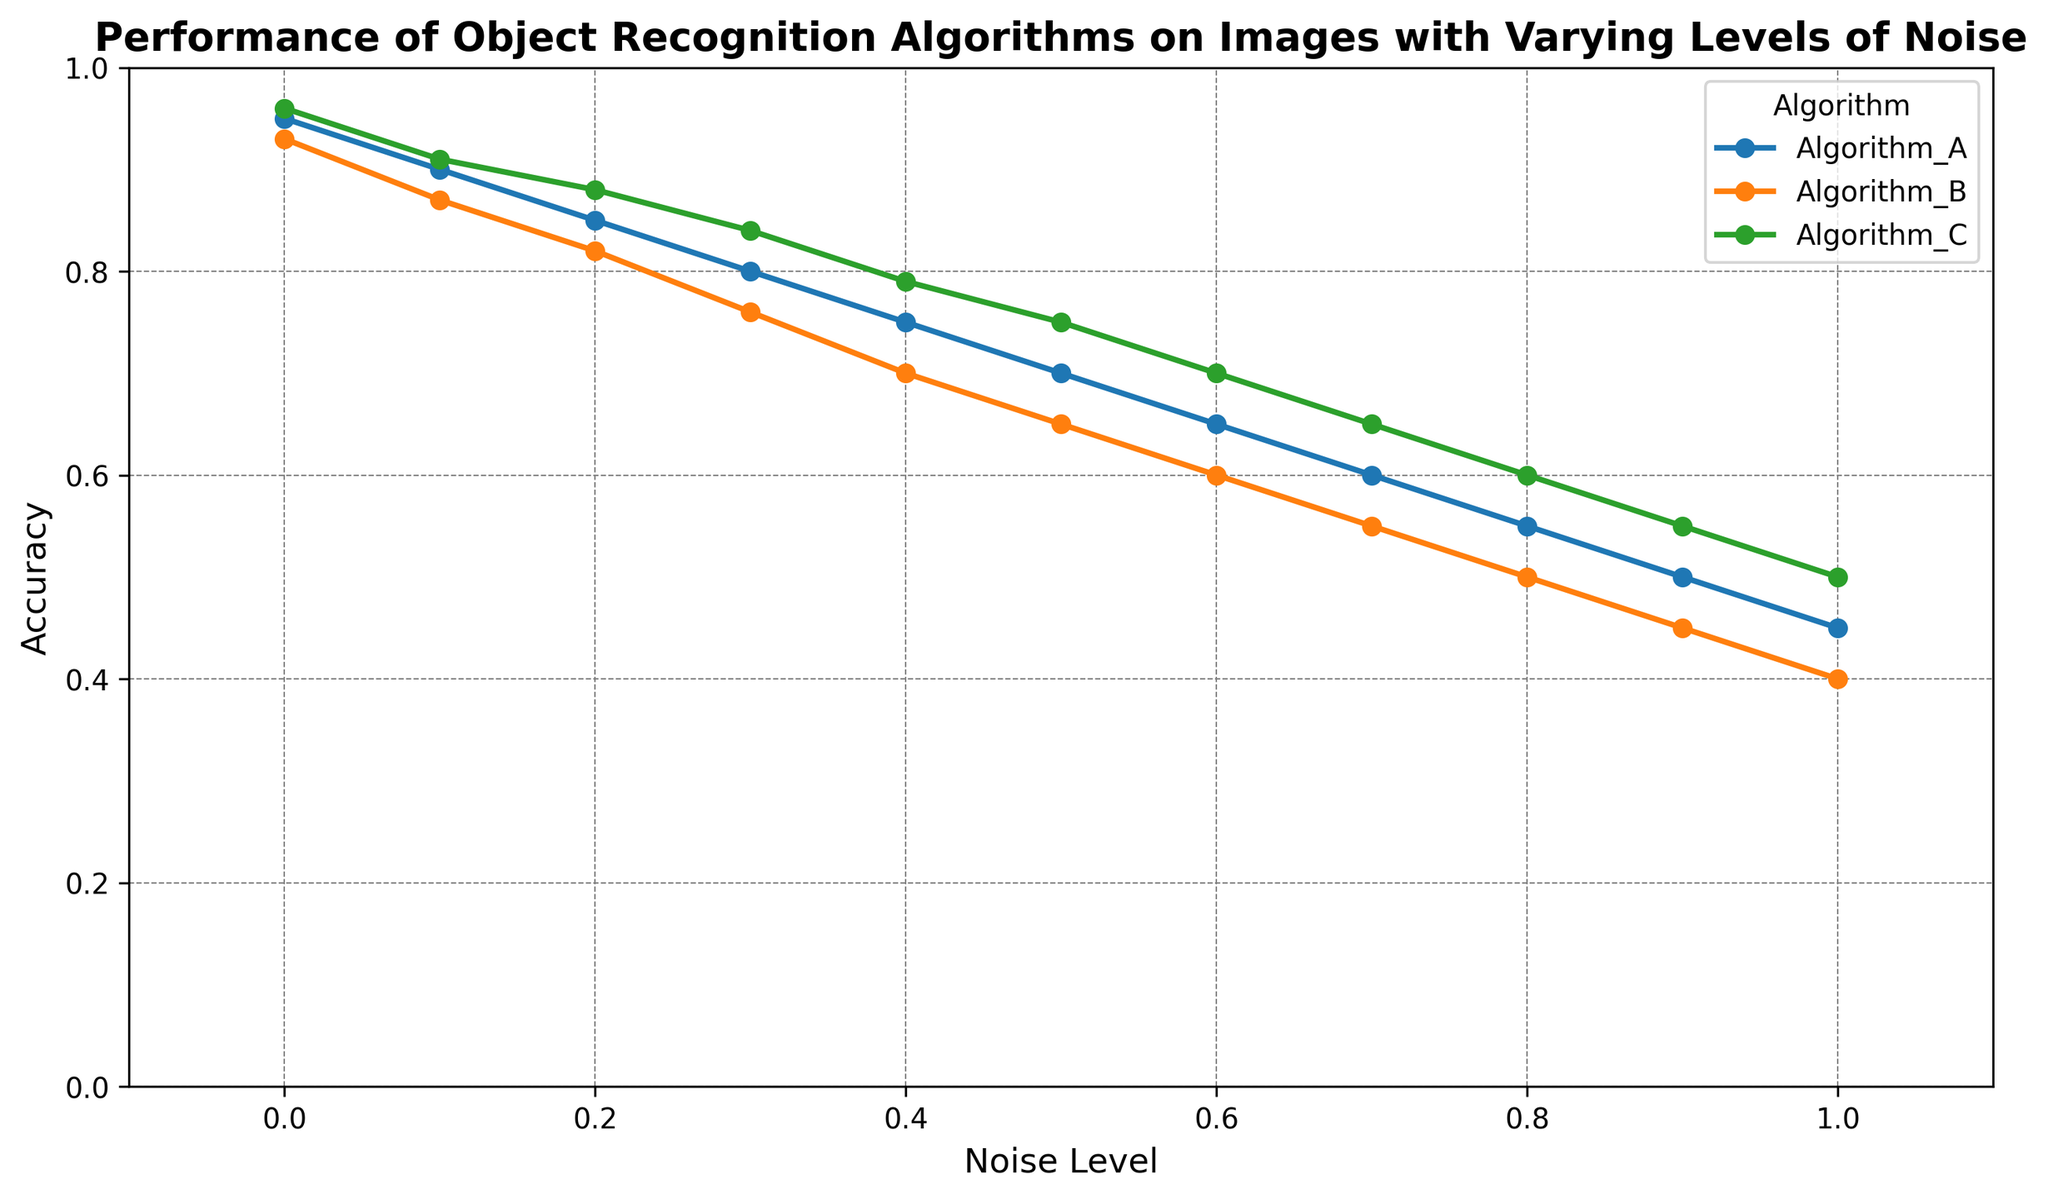What is the highest accuracy achieved by any algorithm at the noise level of 0.3? The chart shows that at a noise level of 0.3, Algorithm C has the highest accuracy of 0.84. This is determined by looking at the values on the y-axis corresponding to the noise level of 0.3 for each algorithm and selecting the maximum value.
Answer: 0.84 Which algorithm performs the best at the maximum noise level of 1.0? Looking at the chart, at the noise level of 1.0, Algorithm C has the highest accuracy with a value of 0.50. This is identified by comparing the accuracies of all three algorithms at the noise level of 1.0.
Answer: Algorithm_C How does the accuracy of Algorithm A change when the noise level increases from 0.2 to 0.5? The accuracy of Algorithm A decreases from 0.85 at the noise level of 0.2 to 0.70 at the noise level of 0.5. The change can be calculated by subtracting the accuracy at 0.5 from the accuracy at 0.2: 0.85 - 0.70 = 0.15.
Answer: Decreases by 0.15 Which algorithm shows the least variation in accuracy across different noise levels? By visually inspecting the chart, Algorithm C has the highest minimum accuracy and the lowest reduction in accuracy as the noise level increases, indicating the most stable performance among the algorithms.
Answer: Algorithm_C At a noise level of 0.8, which algorithm has the lowest accuracy, and what is it? At noise level 0.8, Algorithm B has the lowest accuracy of 0.50. This can be determined by examining the accuracy values for all algorithms at noise level 0.8.
Answer: Algorithm_B, 0.50 What is the average accuracy of Algorithm B across all noise levels? The average accuracy of Algorithm B is calculated by summing the accuracy values and dividing by the number of noise levels. The values are (0.93 + 0.87 + 0.82 + 0.76 + 0.70 + 0.65 + 0.60 + 0.55 + 0.50 + 0.45 + 0.40). Total sum = 7.23, and there are 11 noise levels. The average is 7.23 / 11 ≈ 0.657.
Answer: 0.657 Which algorithm maintains an accuracy above 0.5 at noise level of 0.8? The chart shows that at noise level 0.8, only Algorithm C maintains an accuracy above 0.5 with a value of 0.60.
Answer: Algorithm_C What is the difference in accuracy between Algorithm A and Algorithm B at the noise level 0.6? At noise level 0.6, Algorithm A has an accuracy of 0.65, while Algorithm B has an accuracy of 0.60. The difference is calculated as 0.65 - 0.60 = 0.05.
Answer: 0.05 